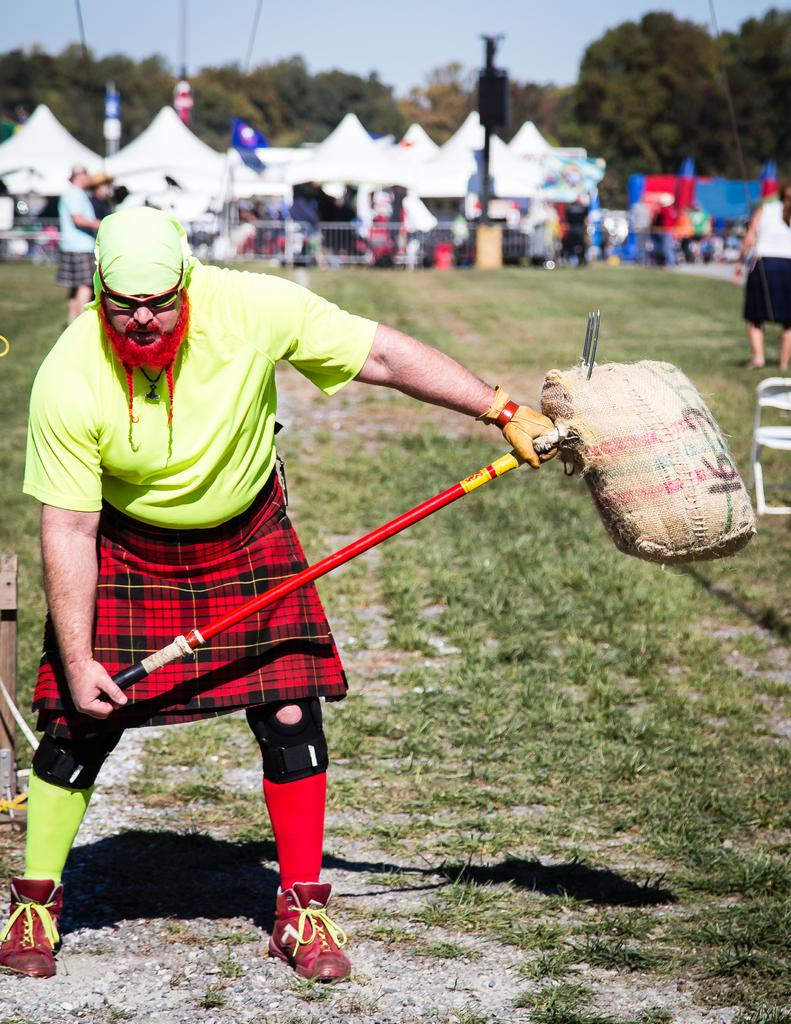What is the main subject of the image? There is a man in the image. What is the man wearing on his upper body? The man is wearing a green t-shirt. What is the man wearing around his waist? The man is wearing a red towel. What can be seen in the background of the image? There are tents and trees in the background of the image. What is visible at the top of the image? The sky is visible at the top of the image. How many icicles are hanging from the man's green t-shirt in the image? There are no icicles present in the image, as it is not a cold environment where icicles would form. 